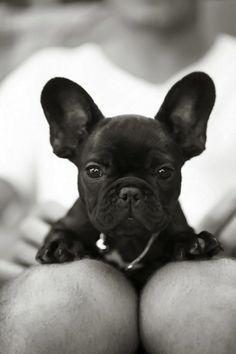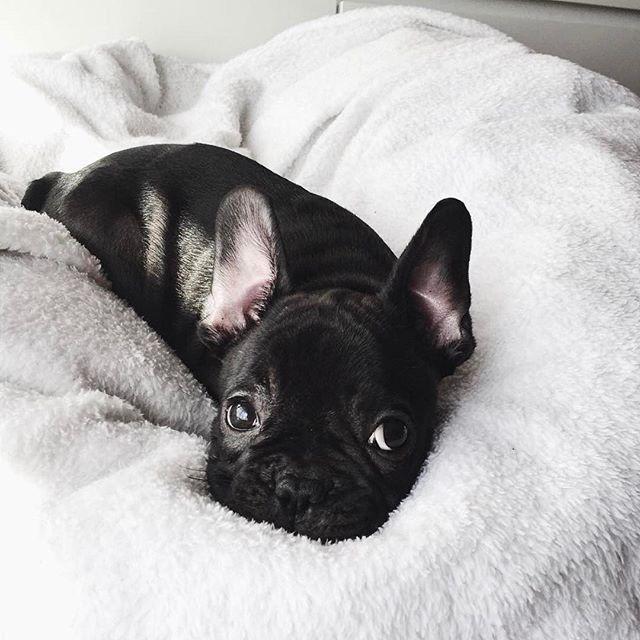The first image is the image on the left, the second image is the image on the right. Considering the images on both sides, is "There are two black French Bulldogs." valid? Answer yes or no. Yes. 